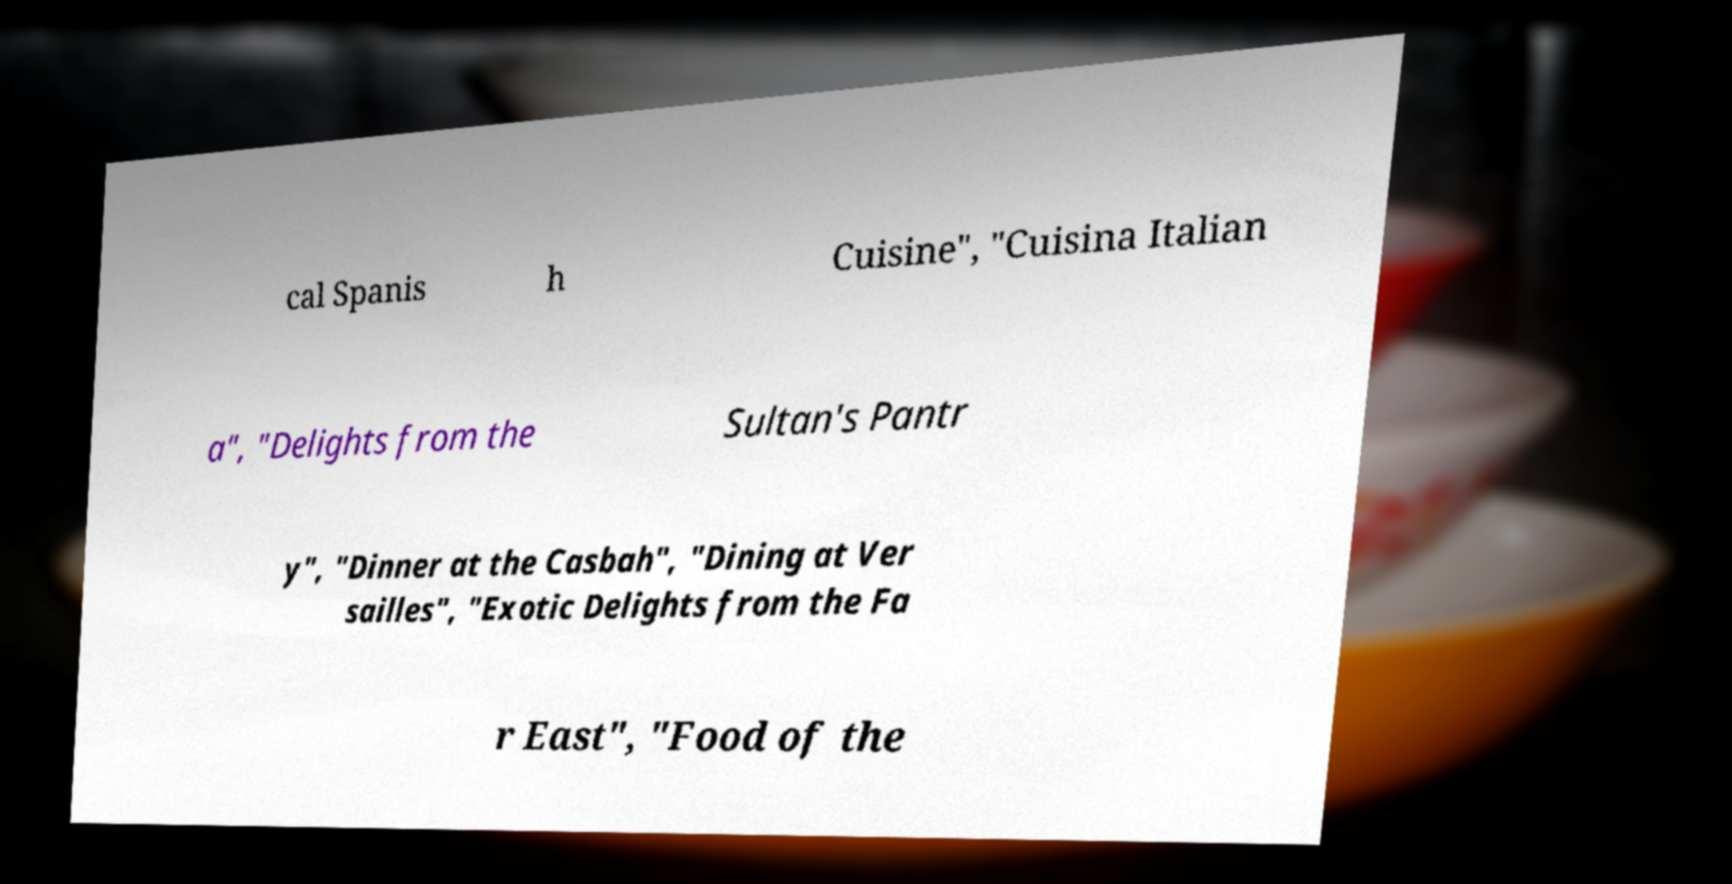Could you assist in decoding the text presented in this image and type it out clearly? cal Spanis h Cuisine", "Cuisina Italian a", "Delights from the Sultan's Pantr y", "Dinner at the Casbah", "Dining at Ver sailles", "Exotic Delights from the Fa r East", "Food of the 